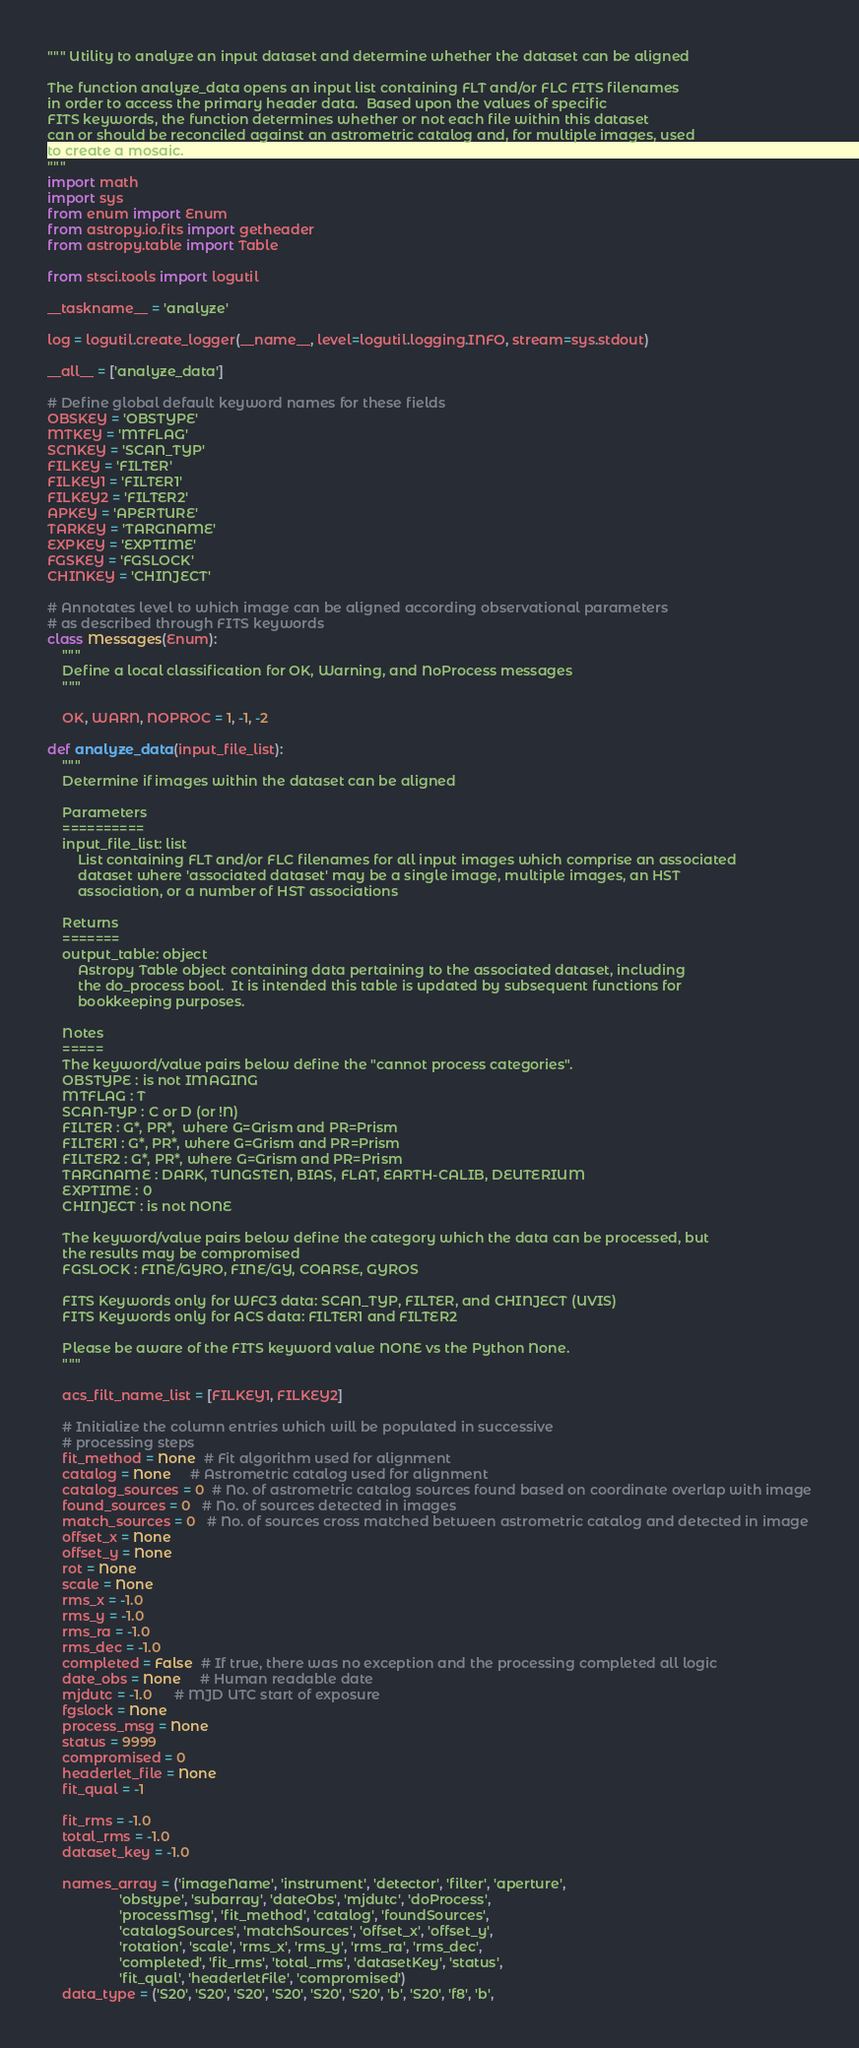<code> <loc_0><loc_0><loc_500><loc_500><_Python_>""" Utility to analyze an input dataset and determine whether the dataset can be aligned

The function analyze_data opens an input list containing FLT and/or FLC FITS filenames
in order to access the primary header data.  Based upon the values of specific
FITS keywords, the function determines whether or not each file within this dataset
can or should be reconciled against an astrometric catalog and, for multiple images, used
to create a mosaic.
"""
import math
import sys
from enum import Enum
from astropy.io.fits import getheader
from astropy.table import Table

from stsci.tools import logutil

__taskname__ = 'analyze'

log = logutil.create_logger(__name__, level=logutil.logging.INFO, stream=sys.stdout)

__all__ = ['analyze_data']

# Define global default keyword names for these fields
OBSKEY = 'OBSTYPE'
MTKEY = 'MTFLAG'
SCNKEY = 'SCAN_TYP'
FILKEY = 'FILTER'
FILKEY1 = 'FILTER1'
FILKEY2 = 'FILTER2'
APKEY = 'APERTURE'
TARKEY = 'TARGNAME'
EXPKEY = 'EXPTIME'
FGSKEY = 'FGSLOCK'
CHINKEY = 'CHINJECT'

# Annotates level to which image can be aligned according observational parameters
# as described through FITS keywords
class Messages(Enum):
    """
    Define a local classification for OK, Warning, and NoProcess messages
    """

    OK, WARN, NOPROC = 1, -1, -2

def analyze_data(input_file_list):
    """
    Determine if images within the dataset can be aligned

    Parameters
    ==========
    input_file_list: list
        List containing FLT and/or FLC filenames for all input images which comprise an associated
        dataset where 'associated dataset' may be a single image, multiple images, an HST
        association, or a number of HST associations

    Returns
    =======
    output_table: object
        Astropy Table object containing data pertaining to the associated dataset, including
        the do_process bool.  It is intended this table is updated by subsequent functions for
        bookkeeping purposes.

    Notes
    =====
    The keyword/value pairs below define the "cannot process categories".
    OBSTYPE : is not IMAGING
    MTFLAG : T
    SCAN-TYP : C or D (or !N)
    FILTER : G*, PR*,  where G=Grism and PR=Prism
    FILTER1 : G*, PR*, where G=Grism and PR=Prism
    FILTER2 : G*, PR*, where G=Grism and PR=Prism
    TARGNAME : DARK, TUNGSTEN, BIAS, FLAT, EARTH-CALIB, DEUTERIUM
    EXPTIME : 0
    CHINJECT : is not NONE

    The keyword/value pairs below define the category which the data can be processed, but
    the results may be compromised
    FGSLOCK : FINE/GYRO, FINE/GY, COARSE, GYROS

    FITS Keywords only for WFC3 data: SCAN_TYP, FILTER, and CHINJECT (UVIS)
    FITS Keywords only for ACS data: FILTER1 and FILTER2

    Please be aware of the FITS keyword value NONE vs the Python None.
    """

    acs_filt_name_list = [FILKEY1, FILKEY2]

    # Initialize the column entries which will be populated in successive
    # processing steps
    fit_method = None  # Fit algorithm used for alignment
    catalog = None     # Astrometric catalog used for alignment
    catalog_sources = 0  # No. of astrometric catalog sources found based on coordinate overlap with image
    found_sources = 0   # No. of sources detected in images
    match_sources = 0   # No. of sources cross matched between astrometric catalog and detected in image
    offset_x = None
    offset_y = None
    rot = None
    scale = None
    rms_x = -1.0
    rms_y = -1.0
    rms_ra = -1.0
    rms_dec = -1.0
    completed = False  # If true, there was no exception and the processing completed all logic
    date_obs = None     # Human readable date
    mjdutc = -1.0      # MJD UTC start of exposure
    fgslock = None
    process_msg = None
    status = 9999
    compromised = 0
    headerlet_file = None
    fit_qual = -1

    fit_rms = -1.0
    total_rms = -1.0
    dataset_key = -1.0

    names_array = ('imageName', 'instrument', 'detector', 'filter', 'aperture',
                   'obstype', 'subarray', 'dateObs', 'mjdutc', 'doProcess',
                   'processMsg', 'fit_method', 'catalog', 'foundSources',
                   'catalogSources', 'matchSources', 'offset_x', 'offset_y',
                   'rotation', 'scale', 'rms_x', 'rms_y', 'rms_ra', 'rms_dec',
                   'completed', 'fit_rms', 'total_rms', 'datasetKey', 'status',
                   'fit_qual', 'headerletFile', 'compromised')
    data_type = ('S20', 'S20', 'S20', 'S20', 'S20', 'S20', 'b', 'S20', 'f8', 'b',</code> 